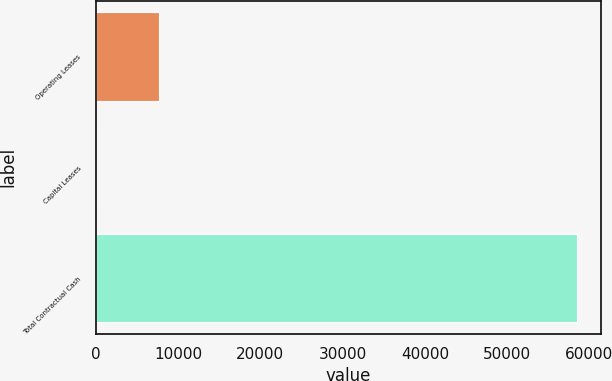Convert chart to OTSL. <chart><loc_0><loc_0><loc_500><loc_500><bar_chart><fcel>Operating Leases<fcel>Capital Leases<fcel>Total Contractual Cash<nl><fcel>7752<fcel>90<fcel>58470<nl></chart> 